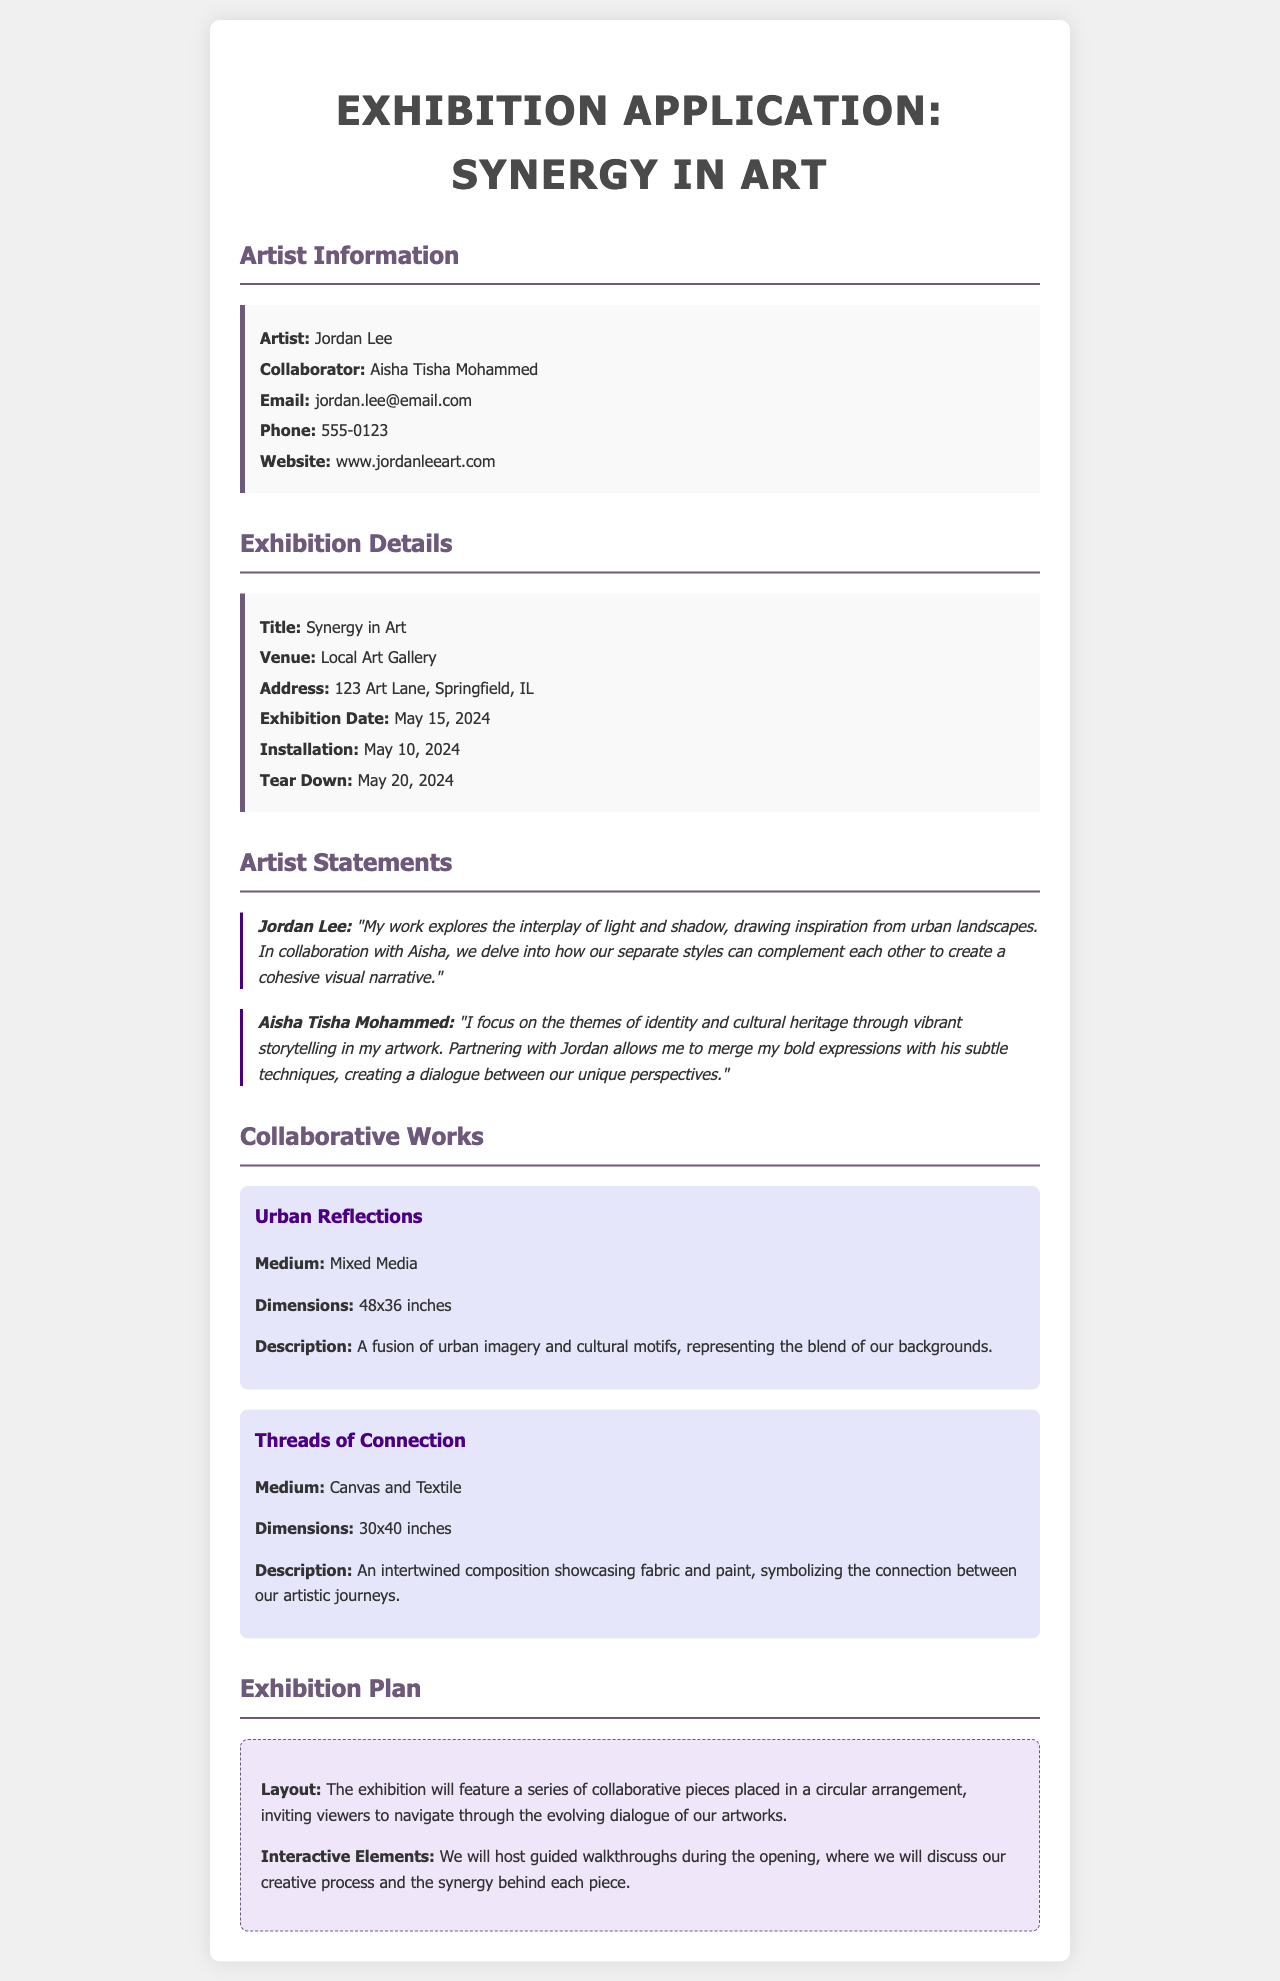what is the title of the exhibition? The title is mentioned in the Exhibition Details section of the document.
Answer: Synergy in Art who is the collaborator of Jordan Lee? The collaborator's name is provided in the Artist Information section.
Answer: Aisha Tisha Mohammed what date is the exhibition scheduled for? The exhibition date can be found in the Exhibition Details section.
Answer: May 15, 2024 what medium is used in the artwork "Urban Reflections"? This information is specified in the Collaborative Works section for that artwork.
Answer: Mixed Media what is the size of the artwork "Threads of Connection"? This dimension is included in the description of the artwork in the document.
Answer: 30x40 inches how will the exhibition layout be arranged? This detail is outlined in the Exhibition Plan section.
Answer: Circular arrangement what themes does Aisha Tisha Mohammed focus on in her artwork? The themes are mentioned in Aisha's artist statement.
Answer: Identity and cultural heritage what interactive elements are planned for the exhibition? The interactive elements are described in the Exhibition Plan section.
Answer: Guided walkthroughs what is the installation date for the exhibition? The installation date is listed in the Exhibition Details section.
Answer: May 10, 2024 